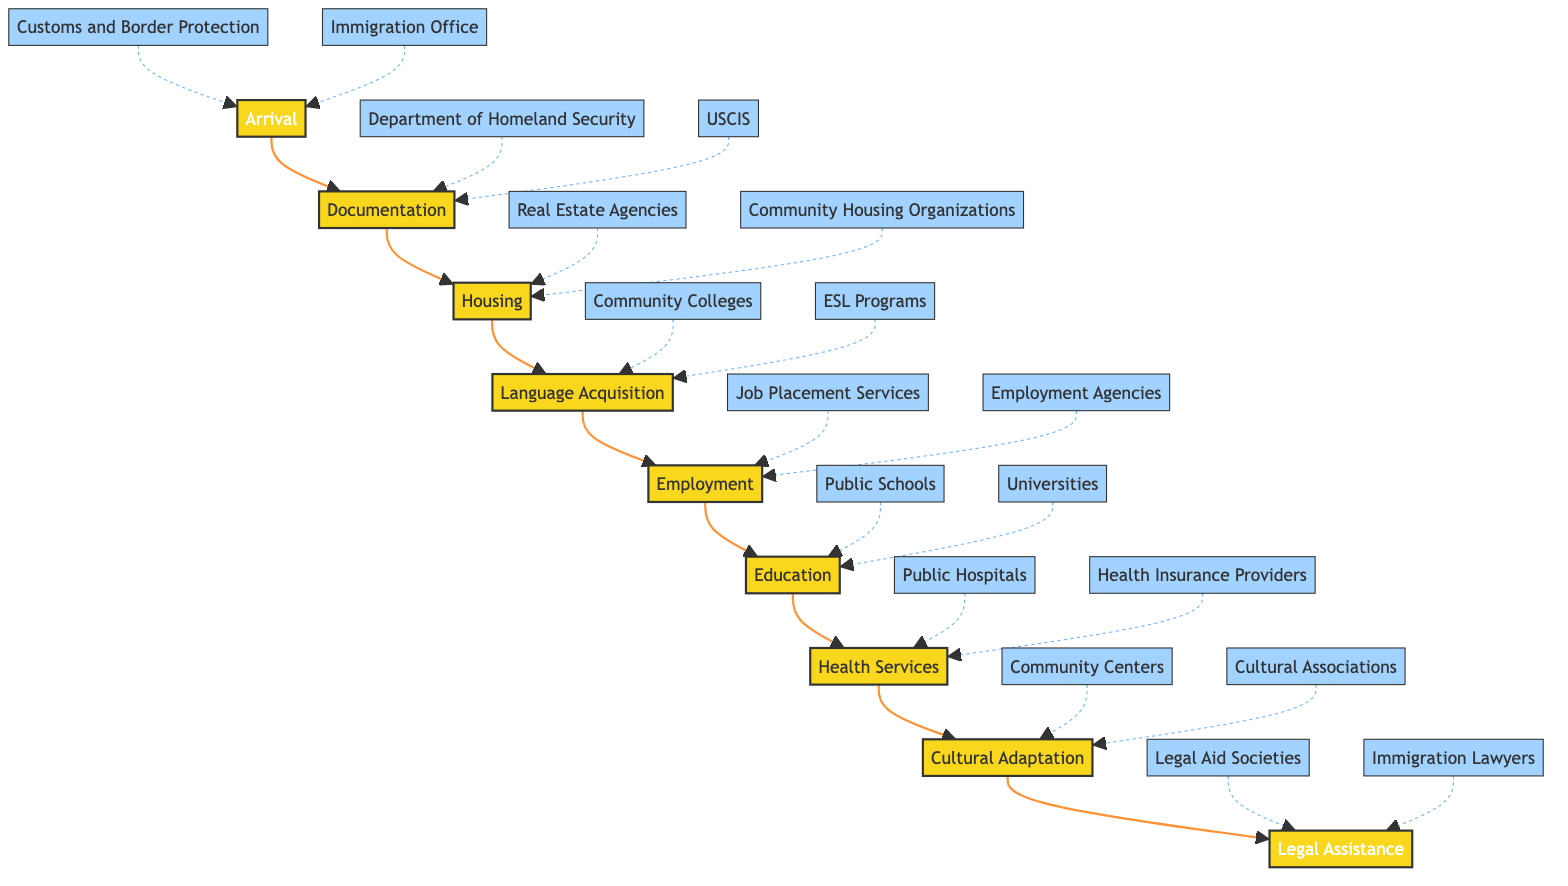What is the first step in the immigrant settlement process? The first step is "Arrival," as indicated at the starting point of the flowchart. It does not connect to any preceding step.
Answer: Arrival Which entity is linked to the "Documentation" step? There are two entities linked to "Documentation": "Department of Homeland Security" and "USCIS." Both are connected to the documentation process in the flowchart.
Answer: Department of Homeland Security, USCIS How many total steps are shown in the diagram? The diagram shows eight steps, listed in sequence from "Arrival" through "Legal Assistance."
Answer: Eight What is the last step of the immigrant settlement process? The last step in the diagram is "Legal Assistance," which is located at the end of the sequence.
Answer: Legal Assistance Which step immediately follows "Housing"? Following "Housing," the next step in the sequence is "Language Acquisition," as indicated by the direct connection from "Housing" to "Language Acquisition."
Answer: Language Acquisition Which entities are associated with the "Employment" step? The "Employment" step is associated with "Job Placement Services" and "Employment Agencies," both of which help in securing jobs.
Answer: Job Placement Services, Employment Agencies What type of organizations may assist with "Cultural Adaptation"? Organizations associated with "Cultural Adaptation" include "Community Centers," "Cultural Associations," and participation in "Local Festivals," as indicated in the diagram.
Answer: Community Centers, Cultural Associations, Local Festivals Identify the step before "Health Services." The step preceding "Health Services" is "Education," as depicted in the flowchart prior to reaching the health services stage.
Answer: Education Which two steps are directly connected to "Language Acquisition"? The steps directly connected to "Language Acquisition" are "Housing" preceding it and "Employment" following it, creating a sequence of forward movement in the settlement process.
Answer: Housing, Employment 